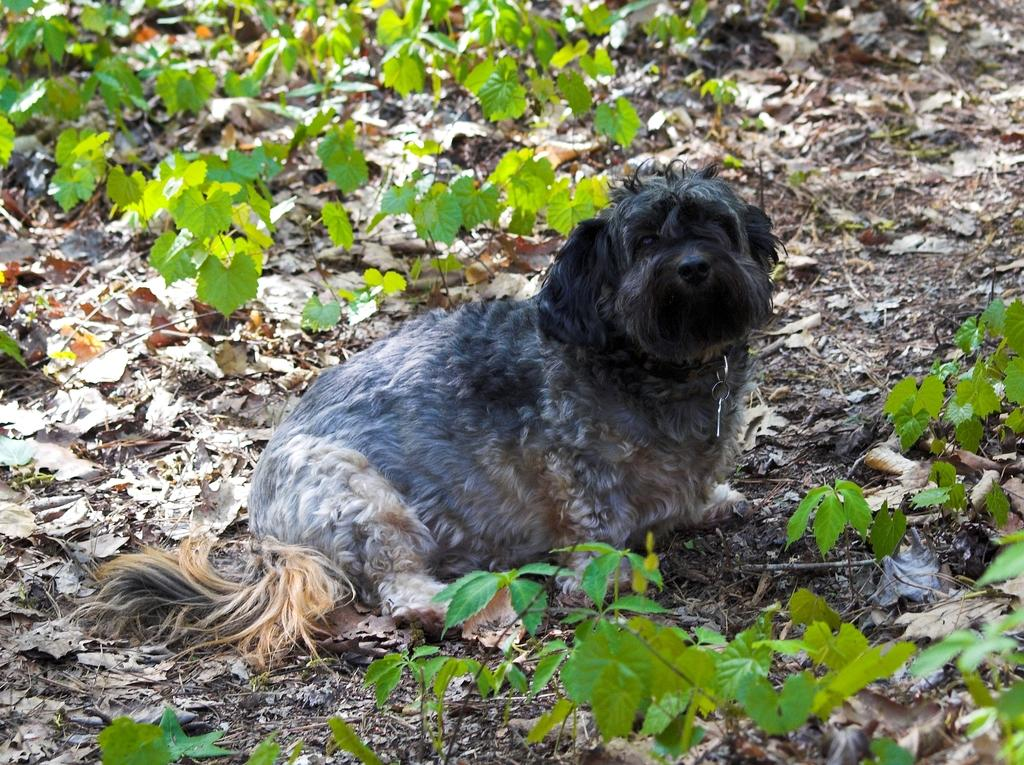What can be seen at the front of the image? There are leaves in the front of the image. What is the main subject in the center of the image? There is an animal in the center of the image. What is present on the ground in the background of the image? There are dry leaves on the ground in the background of the image. What type of vegetation can be seen in the background of the image? There are plants in the background of the image. How many cars are parked next to the animal in the image? There are no cars present in the image; it features leaves, an animal, and plants. What time of day is it in the image, given that it appears to be night? The image does not suggest that it is nighttime, as there is no mention of darkness or nighttime elements. 